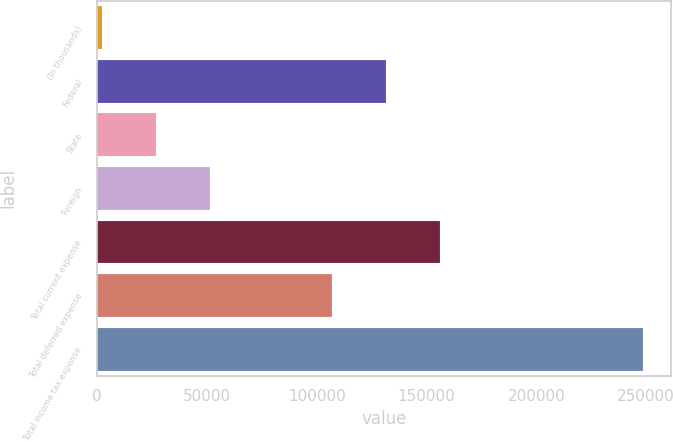Convert chart. <chart><loc_0><loc_0><loc_500><loc_500><bar_chart><fcel>(In thousands)<fcel>Federal<fcel>State<fcel>Foreign<fcel>Total current expense<fcel>Total deferred expense<fcel>Total income tax expense<nl><fcel>2014<fcel>131578<fcel>26686.7<fcel>51359.4<fcel>156250<fcel>106905<fcel>248741<nl></chart> 